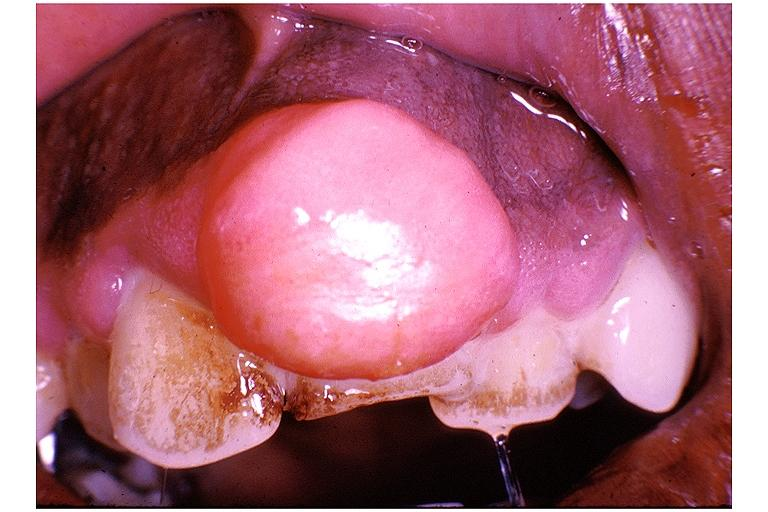where is this?
Answer the question using a single word or phrase. Oral 